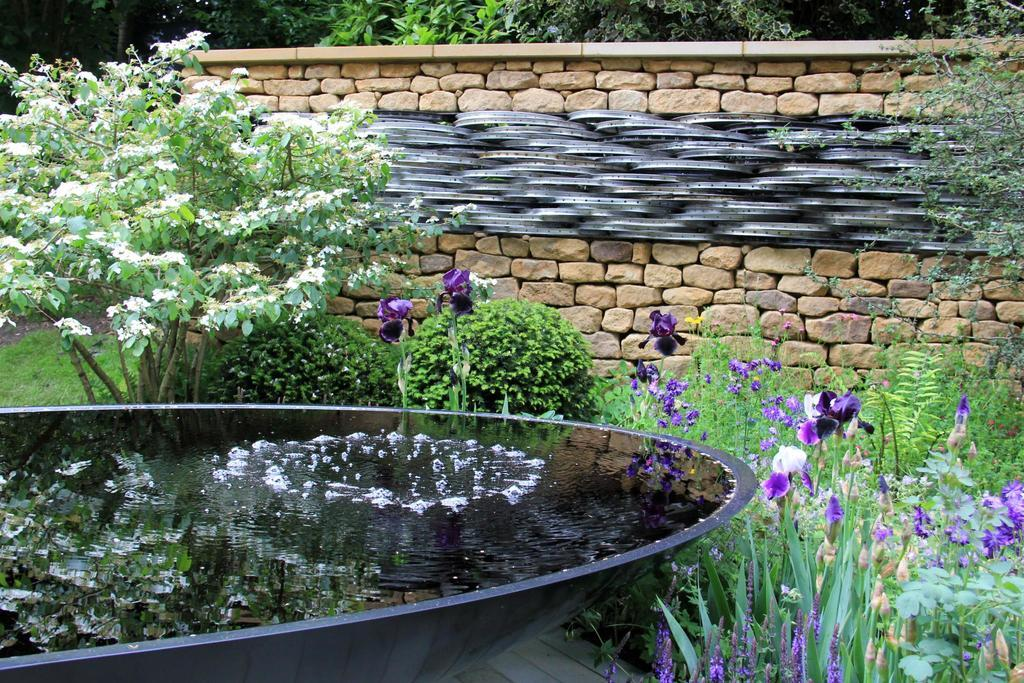What type of vegetation can be seen in the image? There are trees, plants, and shrubs in the image. What structures are present in the image? There are walls in the image. Is there any water visible in the image? Yes, there is water in a pit in the image. What type of rail can be seen connecting the trees in the image? There is no rail present in the image; it only features trees, plants, shrubs, walls, and water in a pit. 